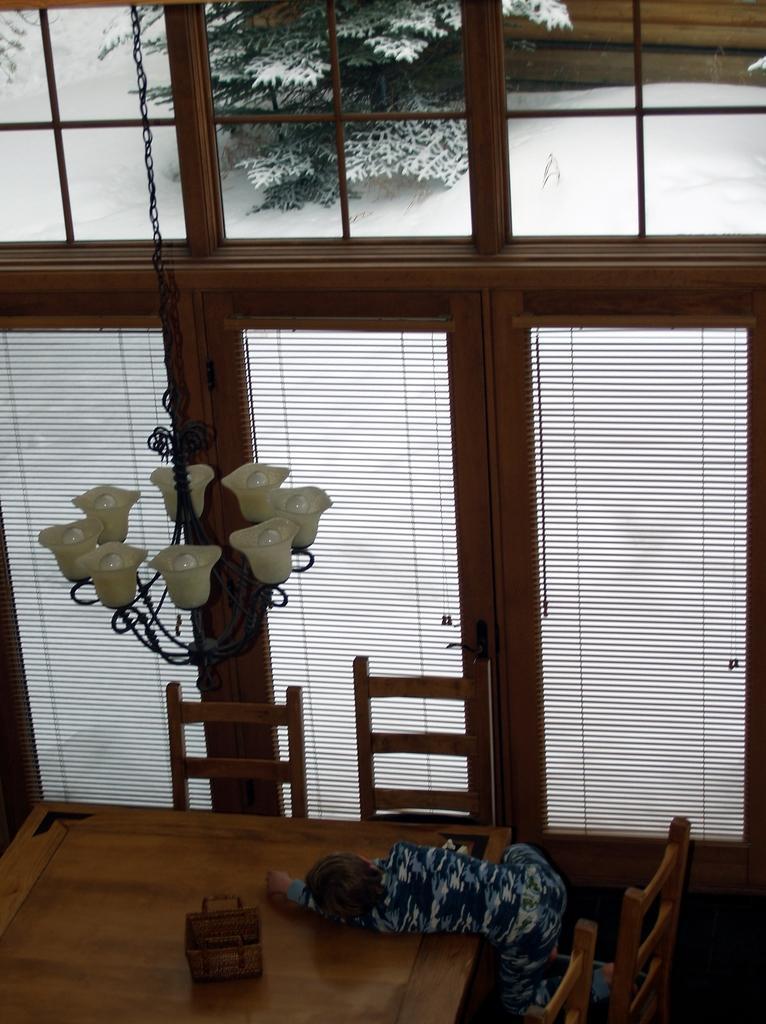Please provide a concise description of this image. In this image there is a table, around the table there are chairs, a child is lying on the table, in the background there is a wall to that wall there are glasses and curtain, from top there is a shandler. 